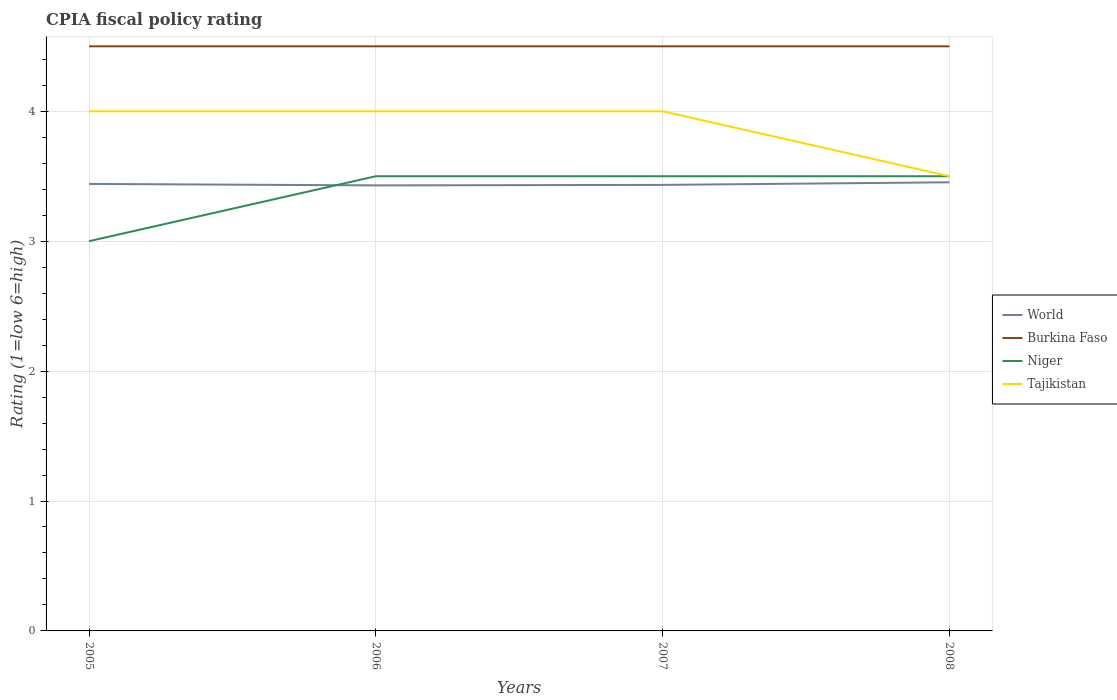Is the number of lines equal to the number of legend labels?
Provide a short and direct response. Yes. Across all years, what is the maximum CPIA rating in Tajikistan?
Ensure brevity in your answer.  3.5. What is the difference between the highest and the second highest CPIA rating in World?
Make the answer very short. 0.02. Is the CPIA rating in Burkina Faso strictly greater than the CPIA rating in Tajikistan over the years?
Offer a very short reply. No. How many lines are there?
Provide a succinct answer. 4. How many years are there in the graph?
Provide a short and direct response. 4. Does the graph contain any zero values?
Your answer should be compact. No. Does the graph contain grids?
Offer a terse response. Yes. What is the title of the graph?
Give a very brief answer. CPIA fiscal policy rating. What is the Rating (1=low 6=high) in World in 2005?
Keep it short and to the point. 3.44. What is the Rating (1=low 6=high) in World in 2006?
Your answer should be very brief. 3.43. What is the Rating (1=low 6=high) in Burkina Faso in 2006?
Provide a short and direct response. 4.5. What is the Rating (1=low 6=high) of Niger in 2006?
Ensure brevity in your answer.  3.5. What is the Rating (1=low 6=high) in Tajikistan in 2006?
Your answer should be compact. 4. What is the Rating (1=low 6=high) in World in 2007?
Provide a short and direct response. 3.43. What is the Rating (1=low 6=high) of Burkina Faso in 2007?
Ensure brevity in your answer.  4.5. What is the Rating (1=low 6=high) in World in 2008?
Give a very brief answer. 3.45. What is the Rating (1=low 6=high) of Tajikistan in 2008?
Provide a succinct answer. 3.5. Across all years, what is the maximum Rating (1=low 6=high) in World?
Provide a short and direct response. 3.45. Across all years, what is the maximum Rating (1=low 6=high) of Tajikistan?
Make the answer very short. 4. Across all years, what is the minimum Rating (1=low 6=high) in World?
Give a very brief answer. 3.43. Across all years, what is the minimum Rating (1=low 6=high) in Tajikistan?
Ensure brevity in your answer.  3.5. What is the total Rating (1=low 6=high) in World in the graph?
Your answer should be compact. 13.76. What is the difference between the Rating (1=low 6=high) in World in 2005 and that in 2006?
Give a very brief answer. 0.01. What is the difference between the Rating (1=low 6=high) in World in 2005 and that in 2007?
Make the answer very short. 0.01. What is the difference between the Rating (1=low 6=high) of World in 2005 and that in 2008?
Your response must be concise. -0.01. What is the difference between the Rating (1=low 6=high) in Niger in 2005 and that in 2008?
Make the answer very short. -0.5. What is the difference between the Rating (1=low 6=high) of World in 2006 and that in 2007?
Ensure brevity in your answer.  -0. What is the difference between the Rating (1=low 6=high) in Tajikistan in 2006 and that in 2007?
Your answer should be compact. 0. What is the difference between the Rating (1=low 6=high) of World in 2006 and that in 2008?
Your answer should be very brief. -0.02. What is the difference between the Rating (1=low 6=high) of Niger in 2006 and that in 2008?
Keep it short and to the point. 0. What is the difference between the Rating (1=low 6=high) in World in 2007 and that in 2008?
Ensure brevity in your answer.  -0.02. What is the difference between the Rating (1=low 6=high) in World in 2005 and the Rating (1=low 6=high) in Burkina Faso in 2006?
Your response must be concise. -1.06. What is the difference between the Rating (1=low 6=high) in World in 2005 and the Rating (1=low 6=high) in Niger in 2006?
Keep it short and to the point. -0.06. What is the difference between the Rating (1=low 6=high) of World in 2005 and the Rating (1=low 6=high) of Tajikistan in 2006?
Make the answer very short. -0.56. What is the difference between the Rating (1=low 6=high) of Niger in 2005 and the Rating (1=low 6=high) of Tajikistan in 2006?
Ensure brevity in your answer.  -1. What is the difference between the Rating (1=low 6=high) of World in 2005 and the Rating (1=low 6=high) of Burkina Faso in 2007?
Offer a terse response. -1.06. What is the difference between the Rating (1=low 6=high) of World in 2005 and the Rating (1=low 6=high) of Niger in 2007?
Provide a succinct answer. -0.06. What is the difference between the Rating (1=low 6=high) of World in 2005 and the Rating (1=low 6=high) of Tajikistan in 2007?
Your response must be concise. -0.56. What is the difference between the Rating (1=low 6=high) in Niger in 2005 and the Rating (1=low 6=high) in Tajikistan in 2007?
Ensure brevity in your answer.  -1. What is the difference between the Rating (1=low 6=high) in World in 2005 and the Rating (1=low 6=high) in Burkina Faso in 2008?
Your response must be concise. -1.06. What is the difference between the Rating (1=low 6=high) of World in 2005 and the Rating (1=low 6=high) of Niger in 2008?
Keep it short and to the point. -0.06. What is the difference between the Rating (1=low 6=high) in World in 2005 and the Rating (1=low 6=high) in Tajikistan in 2008?
Keep it short and to the point. -0.06. What is the difference between the Rating (1=low 6=high) of Burkina Faso in 2005 and the Rating (1=low 6=high) of Niger in 2008?
Your response must be concise. 1. What is the difference between the Rating (1=low 6=high) in Niger in 2005 and the Rating (1=low 6=high) in Tajikistan in 2008?
Offer a very short reply. -0.5. What is the difference between the Rating (1=low 6=high) in World in 2006 and the Rating (1=low 6=high) in Burkina Faso in 2007?
Offer a terse response. -1.07. What is the difference between the Rating (1=low 6=high) of World in 2006 and the Rating (1=low 6=high) of Niger in 2007?
Keep it short and to the point. -0.07. What is the difference between the Rating (1=low 6=high) of World in 2006 and the Rating (1=low 6=high) of Tajikistan in 2007?
Your response must be concise. -0.57. What is the difference between the Rating (1=low 6=high) of Burkina Faso in 2006 and the Rating (1=low 6=high) of Niger in 2007?
Make the answer very short. 1. What is the difference between the Rating (1=low 6=high) of Burkina Faso in 2006 and the Rating (1=low 6=high) of Tajikistan in 2007?
Your answer should be very brief. 0.5. What is the difference between the Rating (1=low 6=high) of World in 2006 and the Rating (1=low 6=high) of Burkina Faso in 2008?
Your answer should be very brief. -1.07. What is the difference between the Rating (1=low 6=high) in World in 2006 and the Rating (1=low 6=high) in Niger in 2008?
Your response must be concise. -0.07. What is the difference between the Rating (1=low 6=high) in World in 2006 and the Rating (1=low 6=high) in Tajikistan in 2008?
Offer a very short reply. -0.07. What is the difference between the Rating (1=low 6=high) of Burkina Faso in 2006 and the Rating (1=low 6=high) of Tajikistan in 2008?
Offer a very short reply. 1. What is the difference between the Rating (1=low 6=high) of Niger in 2006 and the Rating (1=low 6=high) of Tajikistan in 2008?
Give a very brief answer. 0. What is the difference between the Rating (1=low 6=high) of World in 2007 and the Rating (1=low 6=high) of Burkina Faso in 2008?
Ensure brevity in your answer.  -1.07. What is the difference between the Rating (1=low 6=high) in World in 2007 and the Rating (1=low 6=high) in Niger in 2008?
Keep it short and to the point. -0.07. What is the difference between the Rating (1=low 6=high) in World in 2007 and the Rating (1=low 6=high) in Tajikistan in 2008?
Provide a short and direct response. -0.07. What is the difference between the Rating (1=low 6=high) in Niger in 2007 and the Rating (1=low 6=high) in Tajikistan in 2008?
Offer a very short reply. 0. What is the average Rating (1=low 6=high) in World per year?
Keep it short and to the point. 3.44. What is the average Rating (1=low 6=high) in Burkina Faso per year?
Give a very brief answer. 4.5. What is the average Rating (1=low 6=high) of Niger per year?
Keep it short and to the point. 3.38. What is the average Rating (1=low 6=high) of Tajikistan per year?
Provide a short and direct response. 3.88. In the year 2005, what is the difference between the Rating (1=low 6=high) in World and Rating (1=low 6=high) in Burkina Faso?
Ensure brevity in your answer.  -1.06. In the year 2005, what is the difference between the Rating (1=low 6=high) in World and Rating (1=low 6=high) in Niger?
Offer a terse response. 0.44. In the year 2005, what is the difference between the Rating (1=low 6=high) of World and Rating (1=low 6=high) of Tajikistan?
Keep it short and to the point. -0.56. In the year 2005, what is the difference between the Rating (1=low 6=high) in Burkina Faso and Rating (1=low 6=high) in Niger?
Keep it short and to the point. 1.5. In the year 2005, what is the difference between the Rating (1=low 6=high) of Niger and Rating (1=low 6=high) of Tajikistan?
Provide a succinct answer. -1. In the year 2006, what is the difference between the Rating (1=low 6=high) in World and Rating (1=low 6=high) in Burkina Faso?
Provide a short and direct response. -1.07. In the year 2006, what is the difference between the Rating (1=low 6=high) of World and Rating (1=low 6=high) of Niger?
Offer a terse response. -0.07. In the year 2006, what is the difference between the Rating (1=low 6=high) of World and Rating (1=low 6=high) of Tajikistan?
Keep it short and to the point. -0.57. In the year 2006, what is the difference between the Rating (1=low 6=high) of Niger and Rating (1=low 6=high) of Tajikistan?
Provide a succinct answer. -0.5. In the year 2007, what is the difference between the Rating (1=low 6=high) in World and Rating (1=low 6=high) in Burkina Faso?
Keep it short and to the point. -1.07. In the year 2007, what is the difference between the Rating (1=low 6=high) of World and Rating (1=low 6=high) of Niger?
Provide a succinct answer. -0.07. In the year 2007, what is the difference between the Rating (1=low 6=high) in World and Rating (1=low 6=high) in Tajikistan?
Give a very brief answer. -0.57. In the year 2007, what is the difference between the Rating (1=low 6=high) of Burkina Faso and Rating (1=low 6=high) of Niger?
Offer a terse response. 1. In the year 2007, what is the difference between the Rating (1=low 6=high) in Niger and Rating (1=low 6=high) in Tajikistan?
Give a very brief answer. -0.5. In the year 2008, what is the difference between the Rating (1=low 6=high) in World and Rating (1=low 6=high) in Burkina Faso?
Make the answer very short. -1.05. In the year 2008, what is the difference between the Rating (1=low 6=high) of World and Rating (1=low 6=high) of Niger?
Ensure brevity in your answer.  -0.05. In the year 2008, what is the difference between the Rating (1=low 6=high) of World and Rating (1=low 6=high) of Tajikistan?
Your answer should be very brief. -0.05. In the year 2008, what is the difference between the Rating (1=low 6=high) of Niger and Rating (1=low 6=high) of Tajikistan?
Your answer should be very brief. 0. What is the ratio of the Rating (1=low 6=high) of World in 2005 to that in 2006?
Offer a very short reply. 1. What is the ratio of the Rating (1=low 6=high) in Niger in 2005 to that in 2006?
Your answer should be very brief. 0.86. What is the ratio of the Rating (1=low 6=high) in World in 2005 to that in 2007?
Your answer should be very brief. 1. What is the ratio of the Rating (1=low 6=high) in Burkina Faso in 2005 to that in 2007?
Give a very brief answer. 1. What is the ratio of the Rating (1=low 6=high) in Niger in 2005 to that in 2007?
Give a very brief answer. 0.86. What is the ratio of the Rating (1=low 6=high) of Tajikistan in 2005 to that in 2007?
Ensure brevity in your answer.  1. What is the ratio of the Rating (1=low 6=high) in World in 2005 to that in 2008?
Provide a succinct answer. 1. What is the ratio of the Rating (1=low 6=high) in Burkina Faso in 2006 to that in 2007?
Provide a short and direct response. 1. What is the ratio of the Rating (1=low 6=high) in Burkina Faso in 2006 to that in 2008?
Offer a terse response. 1. What is the ratio of the Rating (1=low 6=high) of World in 2007 to that in 2008?
Offer a terse response. 0.99. What is the ratio of the Rating (1=low 6=high) of Burkina Faso in 2007 to that in 2008?
Offer a terse response. 1. What is the difference between the highest and the second highest Rating (1=low 6=high) in World?
Offer a very short reply. 0.01. What is the difference between the highest and the second highest Rating (1=low 6=high) in Burkina Faso?
Your answer should be compact. 0. What is the difference between the highest and the lowest Rating (1=low 6=high) in World?
Provide a short and direct response. 0.02. What is the difference between the highest and the lowest Rating (1=low 6=high) in Tajikistan?
Ensure brevity in your answer.  0.5. 